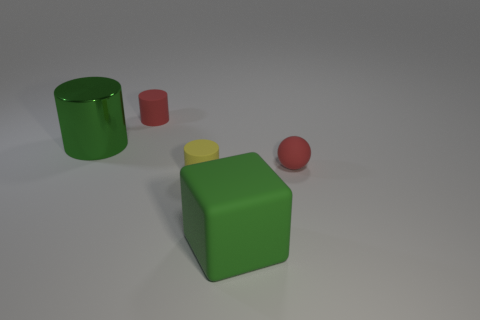How many big cylinders are the same color as the large rubber object?
Your answer should be very brief. 1. There is a matte sphere; is its color the same as the tiny cylinder that is to the left of the tiny yellow thing?
Provide a succinct answer. Yes. Are there fewer rubber things in front of the small red sphere than red matte spheres?
Give a very brief answer. No. The shiny thing has what color?
Give a very brief answer. Green. There is a small rubber object behind the green metallic cylinder; is its color the same as the small rubber sphere?
Offer a terse response. Yes. There is a big thing that is the same shape as the small yellow thing; what color is it?
Provide a short and direct response. Green. What number of tiny objects are matte things or red matte cylinders?
Give a very brief answer. 3. There is a green thing that is left of the big rubber block; what size is it?
Your answer should be very brief. Large. Is there a small thing that has the same color as the small sphere?
Keep it short and to the point. Yes. Is the color of the large cube the same as the metal cylinder?
Offer a terse response. Yes. 